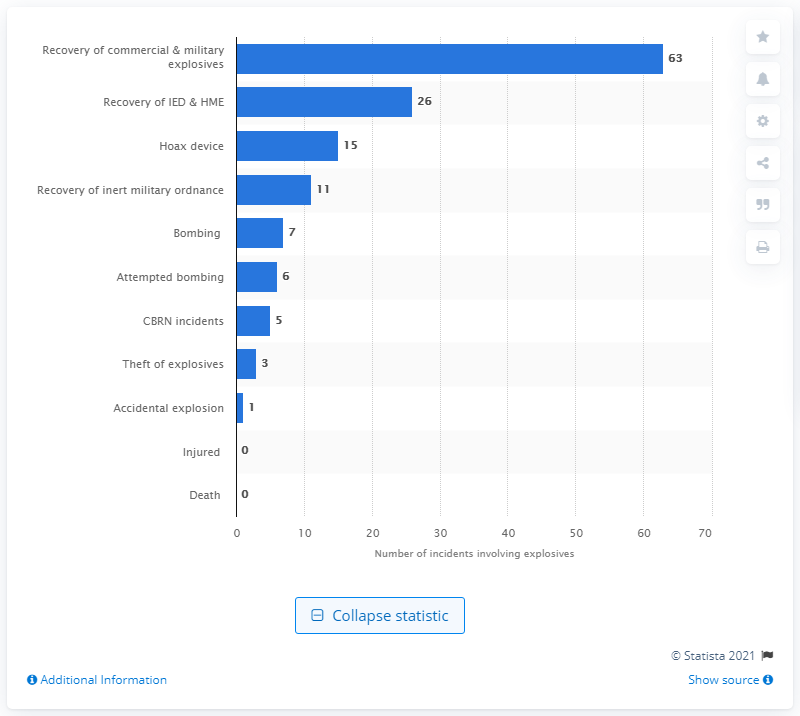List a handful of essential elements in this visual. In 2014, there were 7 reported incidents of bombing in Canada. 